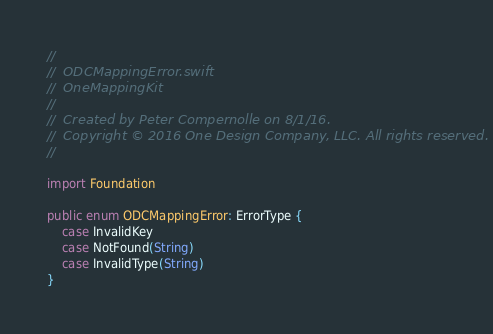<code> <loc_0><loc_0><loc_500><loc_500><_Swift_>//
//  ODCMappingError.swift
//  OneMappingKit
//
//  Created by Peter Compernolle on 8/1/16.
//  Copyright © 2016 One Design Company, LLC. All rights reserved.
//

import Foundation

public enum ODCMappingError: ErrorType {
    case InvalidKey
    case NotFound(String)
    case InvalidType(String)
}</code> 